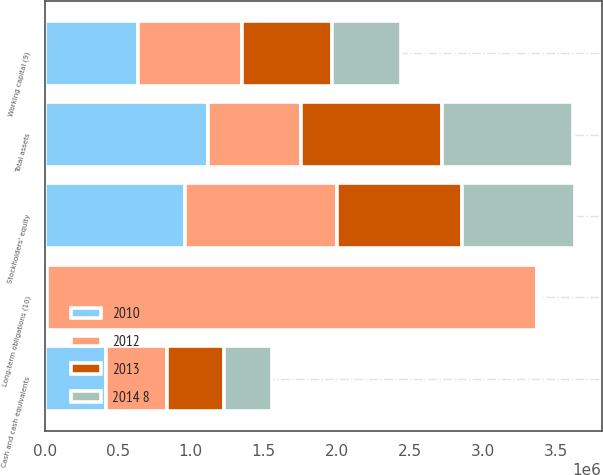Convert chart to OTSL. <chart><loc_0><loc_0><loc_500><loc_500><stacked_bar_chart><ecel><fcel>Cash and cash equivalents<fcel>Working capital (9)<fcel>Total assets<fcel>Long-term obligations (10)<fcel>Stockholders' equity<nl><fcel>2012<fcel>418335<fcel>716203<fcel>635049<fcel>3.35672e+06<fcel>1.03991e+06<nl><fcel>2010<fcel>415795<fcel>635049<fcel>1.11981e+06<fcel>15477<fcel>958658<nl><fcel>2013<fcel>394075<fcel>615649<fcel>967748<fcel>14229<fcel>857002<nl><fcel>2014 8<fcel>326695<fcel>475899<fcel>899006<fcel>11515<fcel>776925<nl></chart> 